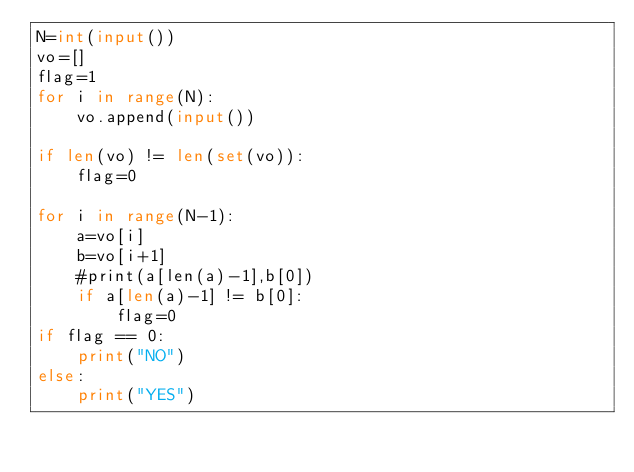Convert code to text. <code><loc_0><loc_0><loc_500><loc_500><_Python_>N=int(input())
vo=[]
flag=1
for i in range(N):
    vo.append(input())
    
if len(vo) != len(set(vo)):
    flag=0
    
for i in range(N-1):
    a=vo[i]
    b=vo[i+1]
    #print(a[len(a)-1],b[0])   
    if a[len(a)-1] != b[0]:
        flag=0    
if flag == 0:
    print("NO")
else:
    print("YES")</code> 